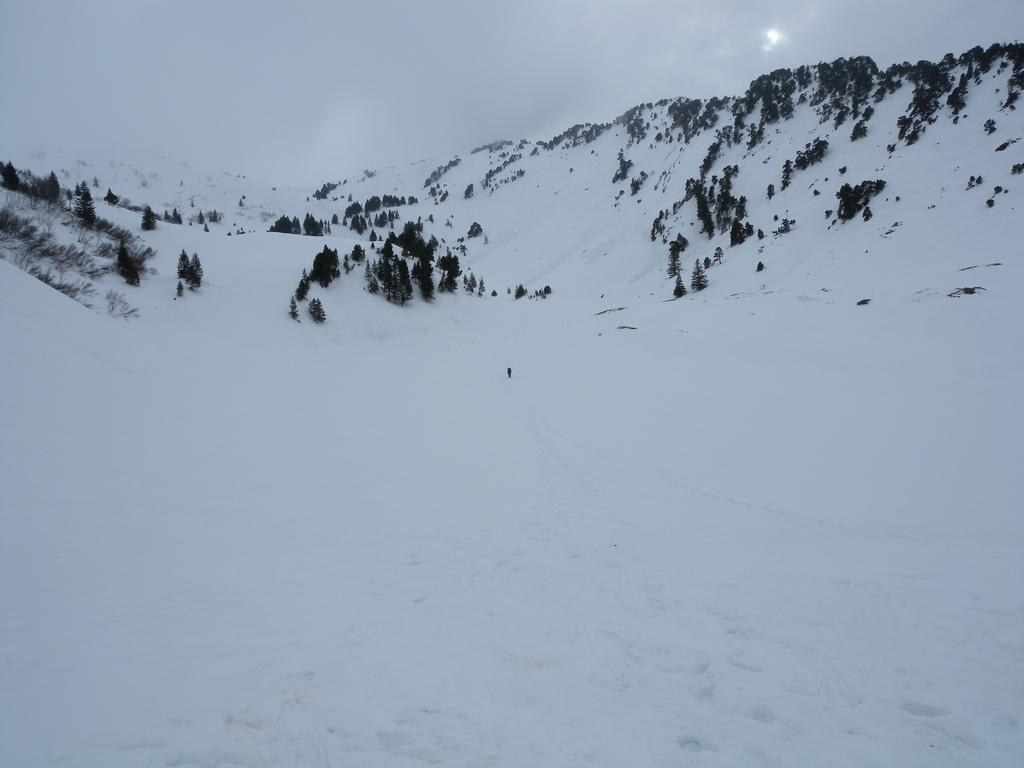What is the color of the snow surface in the image? The snow surface is white in color. What can be seen in the background of the image? There are trees in the background. Where are the trees located? The trees are on mountains. What is the condition of the mountains in the image? The mountains have snow on them. What is visible in the sky in the image? There are clouds in the sky. Where are the apples located in the image? There are no apples present in the image. What type of smoke can be seen coming from the trees in the image? There is no smoke visible in the image; it features snow, trees, mountains, and clouds. 